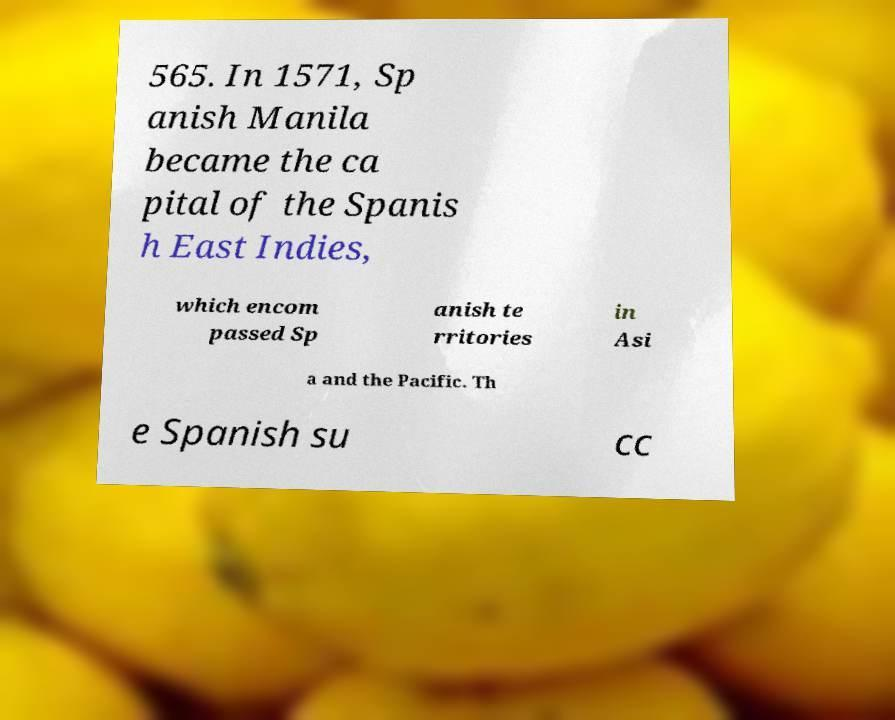Can you read and provide the text displayed in the image?This photo seems to have some interesting text. Can you extract and type it out for me? 565. In 1571, Sp anish Manila became the ca pital of the Spanis h East Indies, which encom passed Sp anish te rritories in Asi a and the Pacific. Th e Spanish su cc 